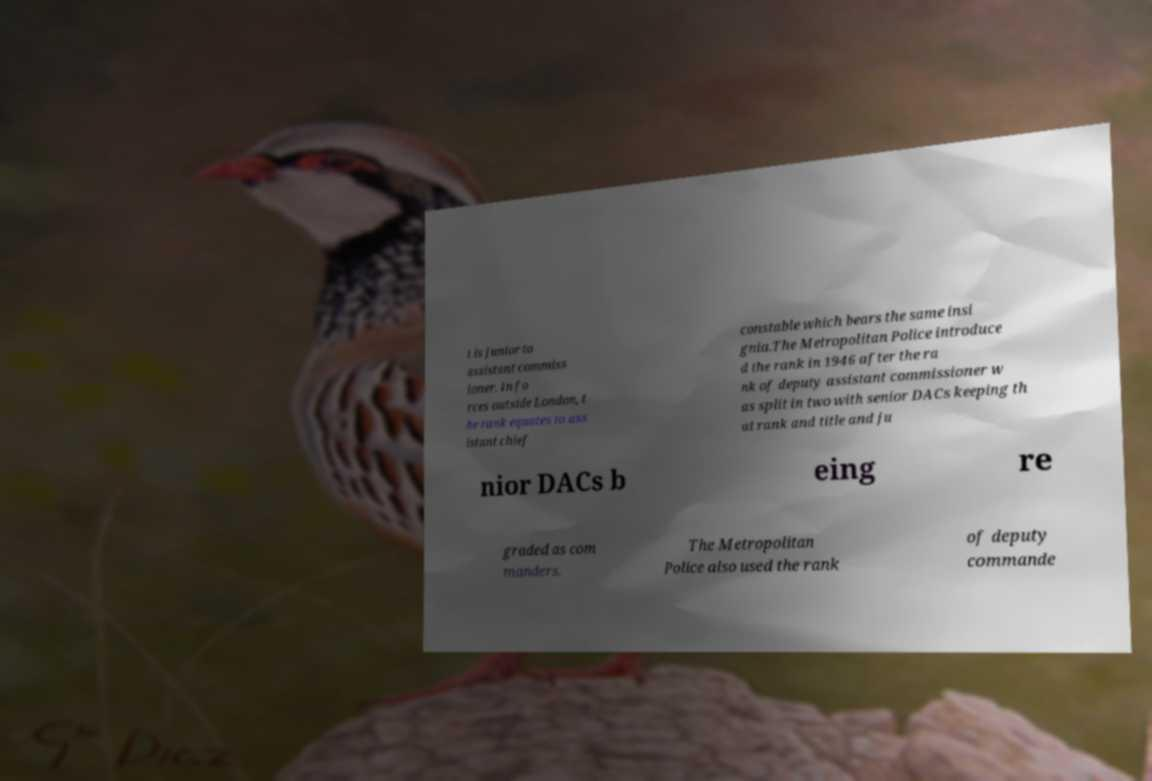For documentation purposes, I need the text within this image transcribed. Could you provide that? t is junior to assistant commiss ioner. In fo rces outside London, t he rank equates to ass istant chief constable which bears the same insi gnia.The Metropolitan Police introduce d the rank in 1946 after the ra nk of deputy assistant commissioner w as split in two with senior DACs keeping th at rank and title and ju nior DACs b eing re graded as com manders. The Metropolitan Police also used the rank of deputy commande 